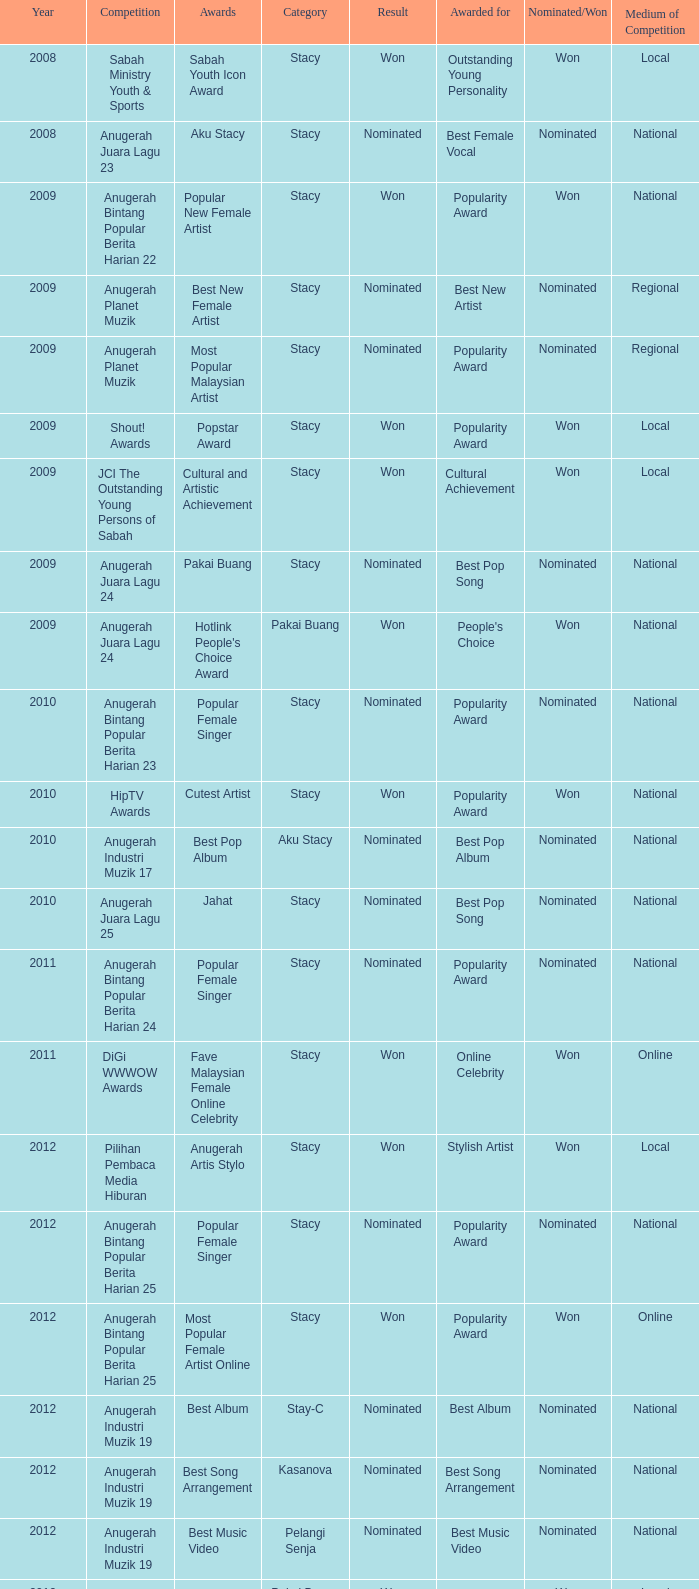I'm looking to parse the entire table for insights. Could you assist me with that? {'header': ['Year', 'Competition', 'Awards', 'Category', 'Result', 'Awarded for', 'Nominated/Won', 'Medium of Competition'], 'rows': [['2008', 'Sabah Ministry Youth & Sports', 'Sabah Youth Icon Award', 'Stacy', 'Won', 'Outstanding Young Personality', 'Won', 'Local'], ['2008', 'Anugerah Juara Lagu 23', 'Aku Stacy', 'Stacy', 'Nominated', 'Best Female Vocal', 'Nominated', 'National'], ['2009', 'Anugerah Bintang Popular Berita Harian 22', 'Popular New Female Artist', 'Stacy', 'Won', 'Popularity Award', 'Won', 'National'], ['2009', 'Anugerah Planet Muzik', 'Best New Female Artist', 'Stacy', 'Nominated', 'Best New Artist', 'Nominated', 'Regional'], ['2009', 'Anugerah Planet Muzik', 'Most Popular Malaysian Artist', 'Stacy', 'Nominated', 'Popularity Award', 'Nominated', 'Regional'], ['2009', 'Shout! Awards', 'Popstar Award', 'Stacy', 'Won', 'Popularity Award', 'Won', 'Local'], ['2009', 'JCI The Outstanding Young Persons of Sabah', 'Cultural and Artistic Achievement', 'Stacy', 'Won', 'Cultural Achievement', 'Won', 'Local'], ['2009', 'Anugerah Juara Lagu 24', 'Pakai Buang', 'Stacy', 'Nominated', 'Best Pop Song', 'Nominated', 'National'], ['2009', 'Anugerah Juara Lagu 24', "Hotlink People's Choice Award", 'Pakai Buang', 'Won', "People's Choice", 'Won', 'National'], ['2010', 'Anugerah Bintang Popular Berita Harian 23', 'Popular Female Singer', 'Stacy', 'Nominated', 'Popularity Award', 'Nominated', 'National'], ['2010', 'HipTV Awards', 'Cutest Artist', 'Stacy', 'Won', 'Popularity Award', 'Won', 'National'], ['2010', 'Anugerah Industri Muzik 17', 'Best Pop Album', 'Aku Stacy', 'Nominated', 'Best Pop Album', 'Nominated', 'National'], ['2010', 'Anugerah Juara Lagu 25', 'Jahat', 'Stacy', 'Nominated', 'Best Pop Song', 'Nominated', 'National'], ['2011', 'Anugerah Bintang Popular Berita Harian 24', 'Popular Female Singer', 'Stacy', 'Nominated', 'Popularity Award', 'Nominated', 'National'], ['2011', 'DiGi WWWOW Awards', 'Fave Malaysian Female Online Celebrity', 'Stacy', 'Won', 'Online Celebrity', 'Won', 'Online'], ['2012', 'Pilihan Pembaca Media Hiburan', 'Anugerah Artis Stylo', 'Stacy', 'Won', 'Stylish Artist', 'Won', 'Local'], ['2012', 'Anugerah Bintang Popular Berita Harian 25', 'Popular Female Singer', 'Stacy', 'Nominated', 'Popularity Award', 'Nominated', 'National'], ['2012', 'Anugerah Bintang Popular Berita Harian 25', 'Most Popular Female Artist Online', 'Stacy', 'Won', 'Popularity Award', 'Won', 'Online'], ['2012', 'Anugerah Industri Muzik 19', 'Best Album', 'Stay-C', 'Nominated', 'Best Album', 'Nominated', 'National'], ['2012', 'Anugerah Industri Muzik 19', 'Best Song Arrangement', 'Kasanova', 'Nominated', 'Best Song Arrangement', 'Nominated', 'National'], ['2012', 'Anugerah Industri Muzik 19', 'Best Music Video', 'Pelangi Senja', 'Nominated', 'Best Music Video', 'Nominated', 'National'], ['2012', 'Anugerah MACP 2012', 'Malay song: Highest Performance Category', 'Pakai Buang', 'Won', 'Best Performance', 'Won', 'Local'], ['2013', 'Anugerah Juara Lagu 27', 'Pelangi Senja', 'Stacy', 'Nominated', 'Best Pop Song', 'Nominated', 'National'], ['2013', 'Shorty Awards (Fifth Annual)', 'Best Singer in Social Media', 'Stacy', 'Nominated', 'Best Singer', 'Nominated', 'Online'], ['2013', 'Shorty Awards (Fifth Annual)', 'Best Reality Star in Social Media', 'Stacy', 'Nominated', 'Best Reality Star', 'Nominated', 'Online'], ['2013', 'Shorty Awards (Fifth Annual)', 'Best Music in Social Media', 'Stacy', 'Nominated', 'Best Music', 'Nominated', 'Online']]} What award was in the year after 2009 with a competition of Digi Wwwow Awards? Fave Malaysian Female Online Celebrity. 